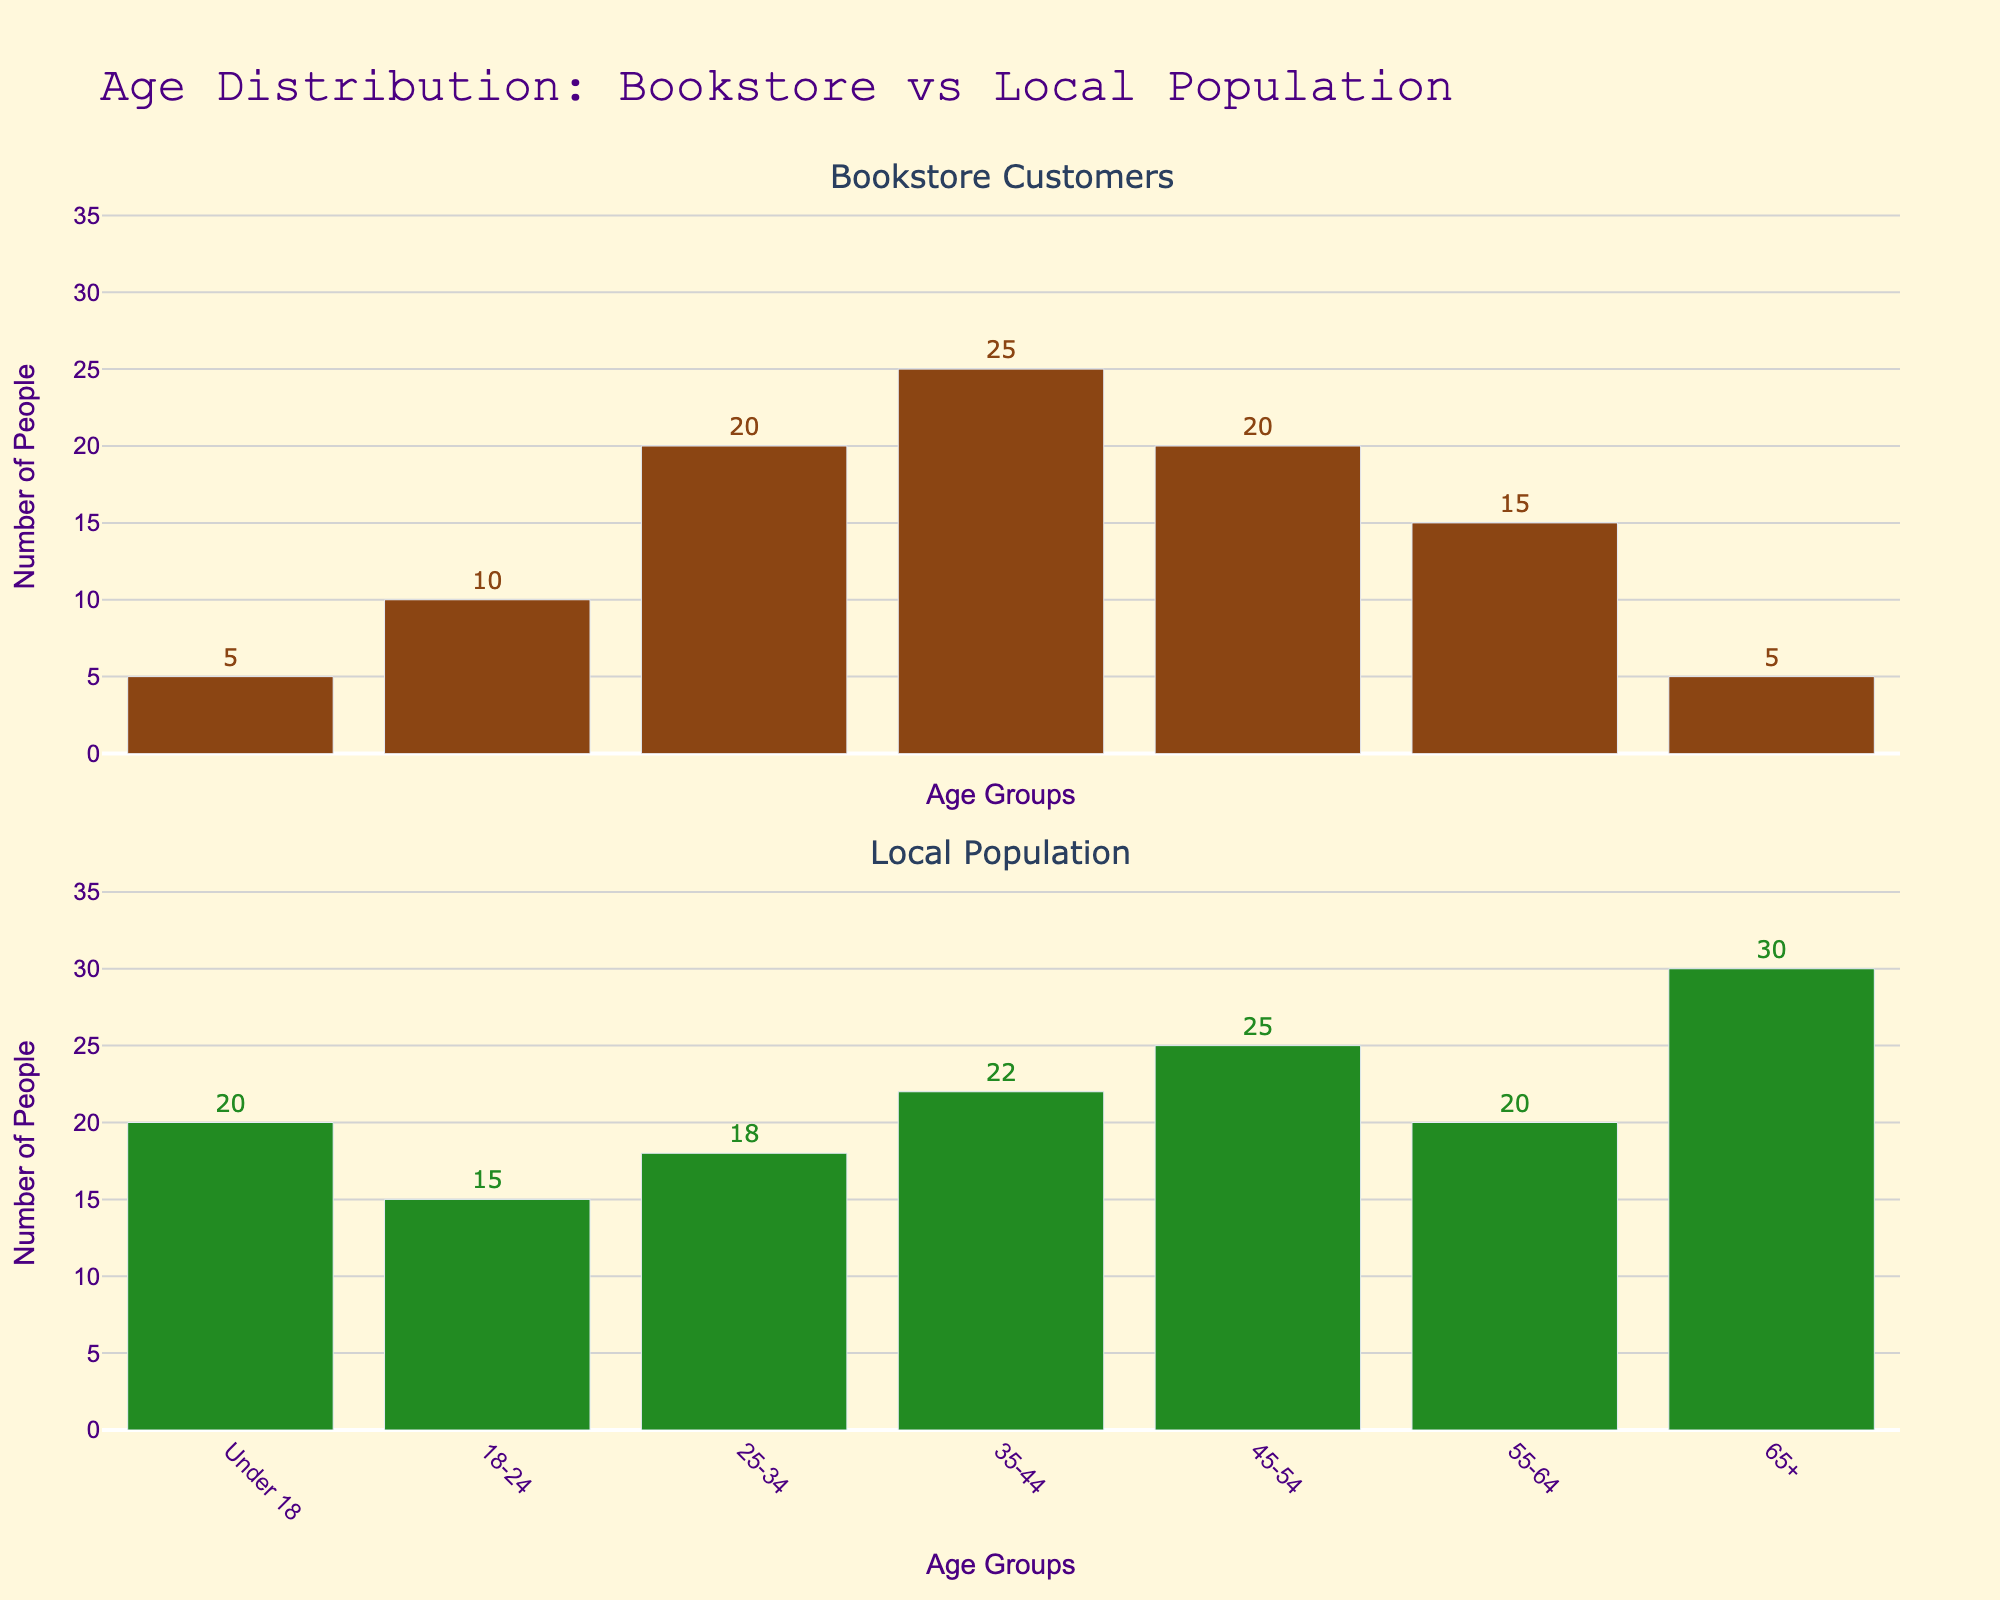What is the title of the figure? The title is usually located at the top of the figure, summarizing its main theme or content.
Answer: Age Distribution: Bookstore vs Local Population What are the age groups displayed on the x-axis? The x-axis lists the different age ranges that are analyzed in the figure.
Answer: Under 18, 18-24, 25-34, 35-44, 45-54, 55-64, 65+ Which age group has the highest number of bookstore customers? By examining the height of the bars in the first subplot corresponding to the number of bookstore customers, we can identify the tallest bar.
Answer: 35-44 What is the difference in the number of people between the local population and bookstore customers in the 55-64 age group? Subtract the number of bookstore customers in the 55-64 age group from the number of local population in the same age group. The respective values are 15 and 20. Therefore, 20 - 15 = 5.
Answer: 5 Compare the number of bookstore customers and local population in the 25-34 age group. Which is greater? Look at the respective height of the bars for the 25-34 age group in both subplots. The bookstore customers' bar is higher.
Answer: Bookstore customers What is the total number of bookstore customers across all age groups? Sum the number of bookstore customers for all age groups: 5 + 10 + 20 + 25 + 20 + 15 + 5 = 100.
Answer: 100 Which age group shows the largest disparity between the number of bookstore customers and the local population? Calculate the absolute differences for each age group and identify the largest one: for Under 18 (15), for 18-24 (5), for 25-34 (2), for 35-44 (3), for 45-54 (5), for 55-64 (5), and for 65+ (25). The largest disparity is in the 65+ age group.
Answer: 65+ In which age group is the number of local population most evenly matched with the bookstore customers? Look for the age group where the bars for the local population and bookstore customers are nearly the same height. That would be the 25-34 age group where the difference is smallest (2).
Answer: 25-34 Compare the number of bookstore customers and local population in the 18-24 age group. Which is lesser? Check the heights of bars in the 18-24 age group. The bookstore customers' bar is shorter.
Answer: Bookstore customers What's the total number of local population across all age groups? Sum the number of local population for all age groups: 20 + 15 + 18 + 22 + 25 + 20 + 30 = 150.
Answer: 150 